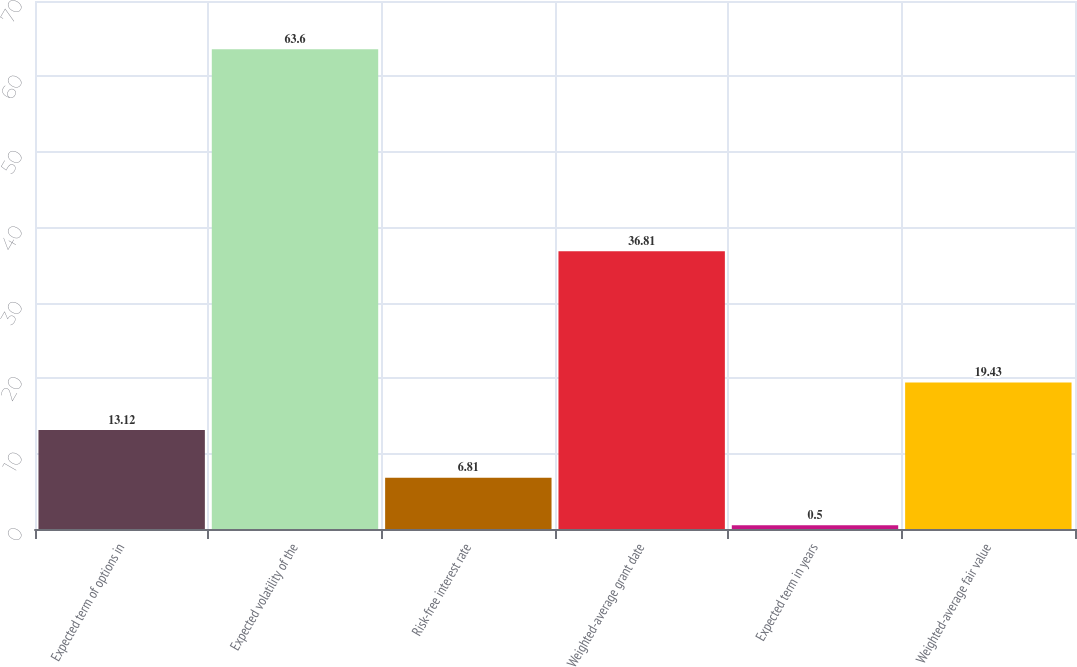<chart> <loc_0><loc_0><loc_500><loc_500><bar_chart><fcel>Expected term of options in<fcel>Expected volatility of the<fcel>Risk-free interest rate<fcel>Weighted-average grant date<fcel>Expected term in years<fcel>Weighted-average fair value<nl><fcel>13.12<fcel>63.6<fcel>6.81<fcel>36.81<fcel>0.5<fcel>19.43<nl></chart> 